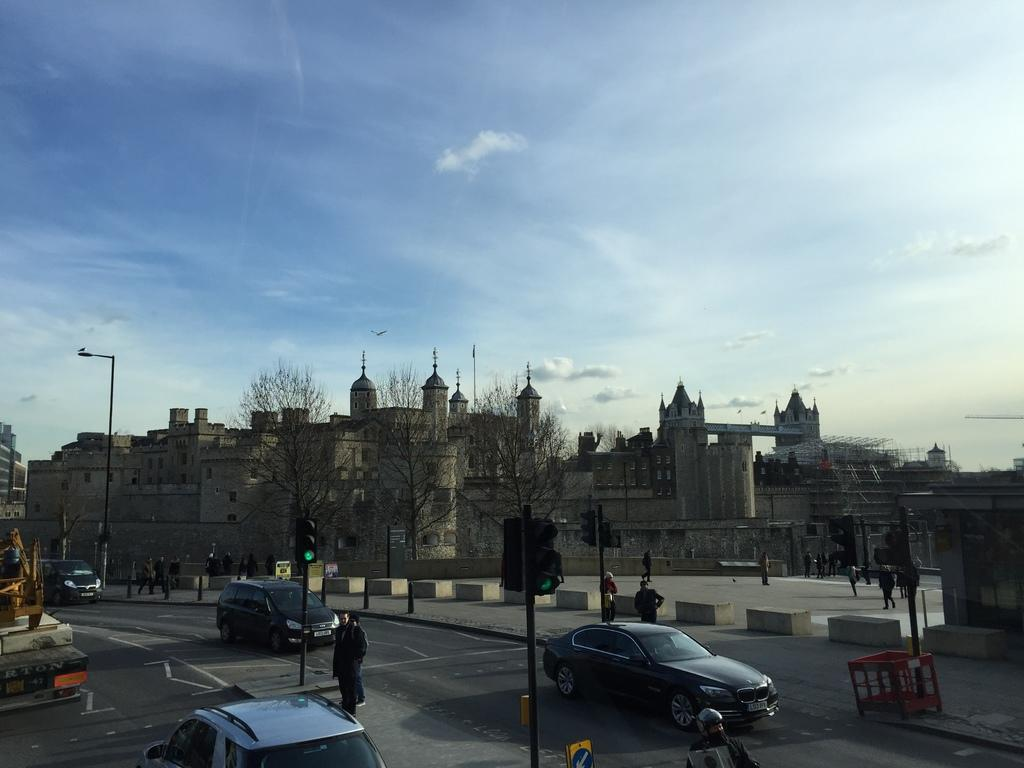What type of structures can be seen in the image? There are buildings in the image. What vehicles are present in the image? There are cars in the image. What type of vegetation is visible in the image? There are trees in the image. What type of lighting infrastructure is present in the image? There are poles with lights in the image. What type of electrical infrastructure is present in the image? There are wires in the image. What type of human activity is visible in the image? There are people on the road in the image. What type of patch can be seen in the middle of the image? There is no patch present in the image. What type of attempt can be seen being made by the people in the image? There is no attempt being made by the people in the image; they are simply walking on the road. 